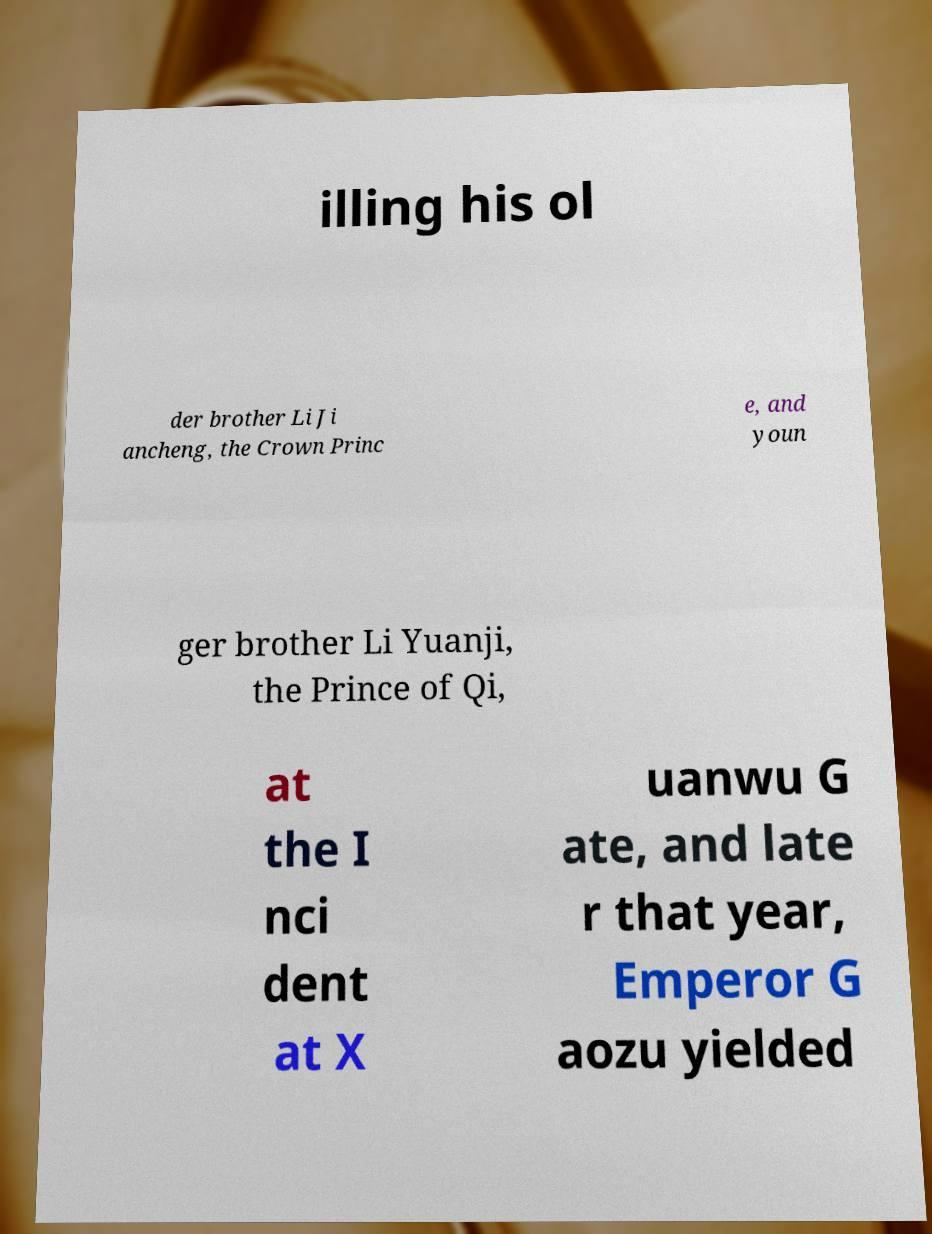I need the written content from this picture converted into text. Can you do that? illing his ol der brother Li Ji ancheng, the Crown Princ e, and youn ger brother Li Yuanji, the Prince of Qi, at the I nci dent at X uanwu G ate, and late r that year, Emperor G aozu yielded 